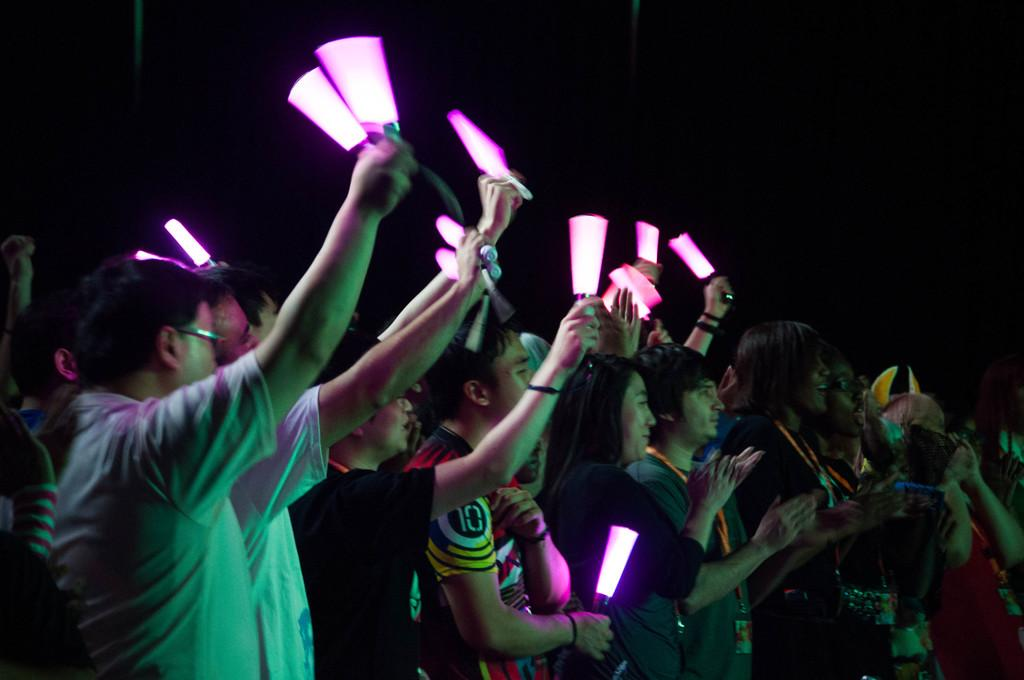How many people are in the image? There are people in the image, but the exact number is not specified. What are some people doing in the image? Some people are holding lights in the image. What can be observed about the background of the image? The background of the image is dark. Reasoning: Let'g: Let's think step by step in order to produce the conversation. We start by acknowledging the presence of people in the image, but we avoid specifying an exact number since it is not mentioned in the facts. Next, we describe the action of some people holding lights, which is a detail provided in the facts. Finally, we mention the dark background, which is another fact about the image. Absurd Question/Answer: Can you see a mountain in the background of the image? No, there is no mention of a mountain in the image. How does the digestion process of the people in the image appear? There is no information about the digestion process of the people in the image. 